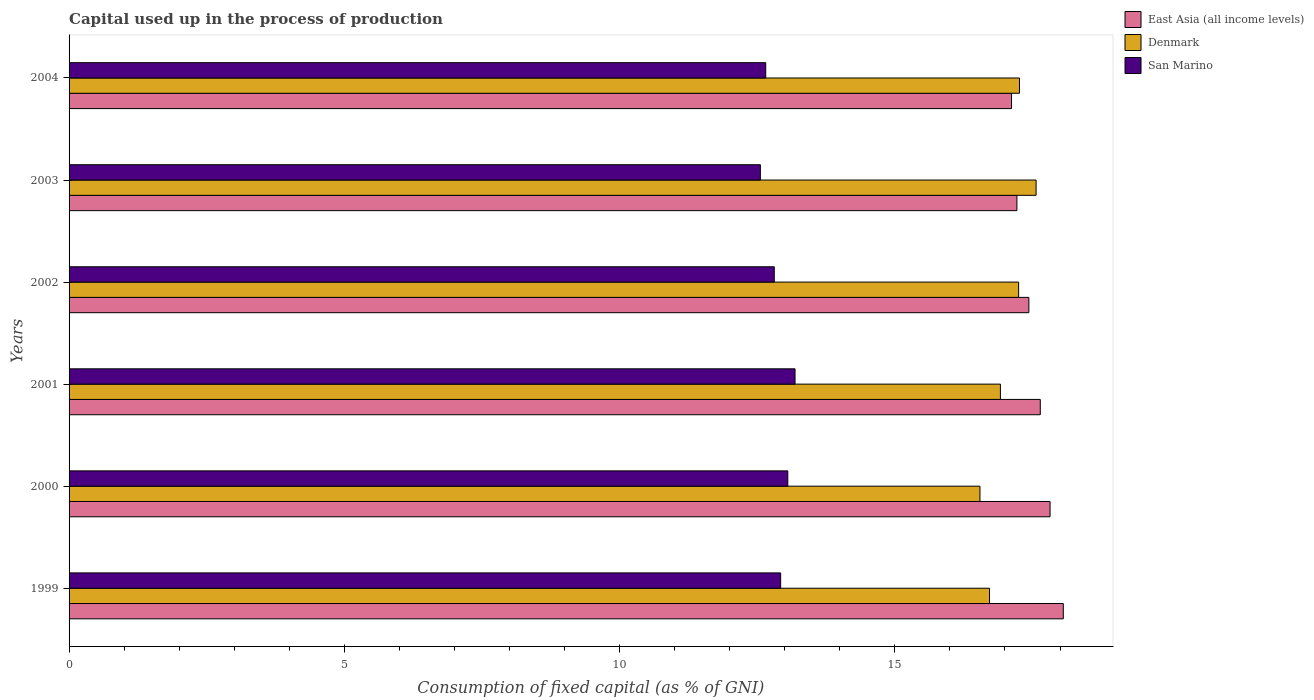How many different coloured bars are there?
Provide a succinct answer. 3. How many groups of bars are there?
Make the answer very short. 6. Are the number of bars per tick equal to the number of legend labels?
Provide a short and direct response. Yes. How many bars are there on the 5th tick from the top?
Provide a succinct answer. 3. In how many cases, is the number of bars for a given year not equal to the number of legend labels?
Make the answer very short. 0. What is the capital used up in the process of production in San Marino in 2004?
Offer a very short reply. 12.65. Across all years, what is the maximum capital used up in the process of production in San Marino?
Provide a succinct answer. 13.19. Across all years, what is the minimum capital used up in the process of production in San Marino?
Your answer should be compact. 12.56. What is the total capital used up in the process of production in East Asia (all income levels) in the graph?
Provide a short and direct response. 105.29. What is the difference between the capital used up in the process of production in Denmark in 2000 and that in 2001?
Your answer should be compact. -0.37. What is the difference between the capital used up in the process of production in Denmark in 2000 and the capital used up in the process of production in East Asia (all income levels) in 1999?
Your answer should be very brief. -1.51. What is the average capital used up in the process of production in East Asia (all income levels) per year?
Give a very brief answer. 17.55. In the year 2003, what is the difference between the capital used up in the process of production in Denmark and capital used up in the process of production in East Asia (all income levels)?
Offer a terse response. 0.35. What is the ratio of the capital used up in the process of production in Denmark in 2001 to that in 2002?
Your answer should be compact. 0.98. Is the difference between the capital used up in the process of production in Denmark in 1999 and 2000 greater than the difference between the capital used up in the process of production in East Asia (all income levels) in 1999 and 2000?
Your answer should be compact. No. What is the difference between the highest and the second highest capital used up in the process of production in East Asia (all income levels)?
Your answer should be compact. 0.24. What is the difference between the highest and the lowest capital used up in the process of production in Denmark?
Offer a terse response. 1.02. Is the sum of the capital used up in the process of production in Denmark in 1999 and 2003 greater than the maximum capital used up in the process of production in San Marino across all years?
Your answer should be compact. Yes. What does the 1st bar from the top in 1999 represents?
Your answer should be very brief. San Marino. How many bars are there?
Keep it short and to the point. 18. Are all the bars in the graph horizontal?
Ensure brevity in your answer.  Yes. How many years are there in the graph?
Provide a short and direct response. 6. Does the graph contain any zero values?
Your answer should be very brief. No. Does the graph contain grids?
Give a very brief answer. No. Where does the legend appear in the graph?
Offer a terse response. Top right. How many legend labels are there?
Keep it short and to the point. 3. How are the legend labels stacked?
Your answer should be compact. Vertical. What is the title of the graph?
Offer a terse response. Capital used up in the process of production. Does "Belgium" appear as one of the legend labels in the graph?
Your response must be concise. No. What is the label or title of the X-axis?
Your response must be concise. Consumption of fixed capital (as % of GNI). What is the Consumption of fixed capital (as % of GNI) in East Asia (all income levels) in 1999?
Ensure brevity in your answer.  18.06. What is the Consumption of fixed capital (as % of GNI) of Denmark in 1999?
Your response must be concise. 16.72. What is the Consumption of fixed capital (as % of GNI) of San Marino in 1999?
Your answer should be compact. 12.93. What is the Consumption of fixed capital (as % of GNI) in East Asia (all income levels) in 2000?
Provide a short and direct response. 17.82. What is the Consumption of fixed capital (as % of GNI) in Denmark in 2000?
Ensure brevity in your answer.  16.55. What is the Consumption of fixed capital (as % of GNI) in San Marino in 2000?
Your answer should be very brief. 13.06. What is the Consumption of fixed capital (as % of GNI) in East Asia (all income levels) in 2001?
Your answer should be compact. 17.64. What is the Consumption of fixed capital (as % of GNI) of Denmark in 2001?
Your answer should be very brief. 16.92. What is the Consumption of fixed capital (as % of GNI) of San Marino in 2001?
Keep it short and to the point. 13.19. What is the Consumption of fixed capital (as % of GNI) of East Asia (all income levels) in 2002?
Give a very brief answer. 17.43. What is the Consumption of fixed capital (as % of GNI) of Denmark in 2002?
Your response must be concise. 17.25. What is the Consumption of fixed capital (as % of GNI) in San Marino in 2002?
Your answer should be compact. 12.81. What is the Consumption of fixed capital (as % of GNI) in East Asia (all income levels) in 2003?
Offer a terse response. 17.22. What is the Consumption of fixed capital (as % of GNI) in Denmark in 2003?
Provide a succinct answer. 17.57. What is the Consumption of fixed capital (as % of GNI) of San Marino in 2003?
Offer a very short reply. 12.56. What is the Consumption of fixed capital (as % of GNI) in East Asia (all income levels) in 2004?
Keep it short and to the point. 17.12. What is the Consumption of fixed capital (as % of GNI) in Denmark in 2004?
Make the answer very short. 17.26. What is the Consumption of fixed capital (as % of GNI) in San Marino in 2004?
Keep it short and to the point. 12.65. Across all years, what is the maximum Consumption of fixed capital (as % of GNI) in East Asia (all income levels)?
Make the answer very short. 18.06. Across all years, what is the maximum Consumption of fixed capital (as % of GNI) of Denmark?
Your answer should be compact. 17.57. Across all years, what is the maximum Consumption of fixed capital (as % of GNI) in San Marino?
Make the answer very short. 13.19. Across all years, what is the minimum Consumption of fixed capital (as % of GNI) of East Asia (all income levels)?
Provide a succinct answer. 17.12. Across all years, what is the minimum Consumption of fixed capital (as % of GNI) in Denmark?
Ensure brevity in your answer.  16.55. Across all years, what is the minimum Consumption of fixed capital (as % of GNI) in San Marino?
Keep it short and to the point. 12.56. What is the total Consumption of fixed capital (as % of GNI) of East Asia (all income levels) in the graph?
Give a very brief answer. 105.29. What is the total Consumption of fixed capital (as % of GNI) in Denmark in the graph?
Ensure brevity in your answer.  102.26. What is the total Consumption of fixed capital (as % of GNI) of San Marino in the graph?
Give a very brief answer. 77.19. What is the difference between the Consumption of fixed capital (as % of GNI) in East Asia (all income levels) in 1999 and that in 2000?
Offer a very short reply. 0.24. What is the difference between the Consumption of fixed capital (as % of GNI) of Denmark in 1999 and that in 2000?
Your answer should be compact. 0.17. What is the difference between the Consumption of fixed capital (as % of GNI) in San Marino in 1999 and that in 2000?
Keep it short and to the point. -0.13. What is the difference between the Consumption of fixed capital (as % of GNI) of East Asia (all income levels) in 1999 and that in 2001?
Keep it short and to the point. 0.42. What is the difference between the Consumption of fixed capital (as % of GNI) in Denmark in 1999 and that in 2001?
Provide a succinct answer. -0.2. What is the difference between the Consumption of fixed capital (as % of GNI) in San Marino in 1999 and that in 2001?
Offer a terse response. -0.26. What is the difference between the Consumption of fixed capital (as % of GNI) of East Asia (all income levels) in 1999 and that in 2002?
Your response must be concise. 0.63. What is the difference between the Consumption of fixed capital (as % of GNI) in Denmark in 1999 and that in 2002?
Your answer should be very brief. -0.53. What is the difference between the Consumption of fixed capital (as % of GNI) in San Marino in 1999 and that in 2002?
Give a very brief answer. 0.12. What is the difference between the Consumption of fixed capital (as % of GNI) of East Asia (all income levels) in 1999 and that in 2003?
Provide a succinct answer. 0.84. What is the difference between the Consumption of fixed capital (as % of GNI) of Denmark in 1999 and that in 2003?
Make the answer very short. -0.85. What is the difference between the Consumption of fixed capital (as % of GNI) of San Marino in 1999 and that in 2003?
Ensure brevity in your answer.  0.37. What is the difference between the Consumption of fixed capital (as % of GNI) of East Asia (all income levels) in 1999 and that in 2004?
Provide a short and direct response. 0.94. What is the difference between the Consumption of fixed capital (as % of GNI) in Denmark in 1999 and that in 2004?
Your answer should be compact. -0.54. What is the difference between the Consumption of fixed capital (as % of GNI) in San Marino in 1999 and that in 2004?
Ensure brevity in your answer.  0.27. What is the difference between the Consumption of fixed capital (as % of GNI) of East Asia (all income levels) in 2000 and that in 2001?
Provide a succinct answer. 0.18. What is the difference between the Consumption of fixed capital (as % of GNI) in Denmark in 2000 and that in 2001?
Offer a terse response. -0.37. What is the difference between the Consumption of fixed capital (as % of GNI) of San Marino in 2000 and that in 2001?
Offer a terse response. -0.13. What is the difference between the Consumption of fixed capital (as % of GNI) in East Asia (all income levels) in 2000 and that in 2002?
Your answer should be compact. 0.38. What is the difference between the Consumption of fixed capital (as % of GNI) of Denmark in 2000 and that in 2002?
Offer a very short reply. -0.7. What is the difference between the Consumption of fixed capital (as % of GNI) in San Marino in 2000 and that in 2002?
Provide a short and direct response. 0.25. What is the difference between the Consumption of fixed capital (as % of GNI) of East Asia (all income levels) in 2000 and that in 2003?
Your answer should be very brief. 0.6. What is the difference between the Consumption of fixed capital (as % of GNI) in Denmark in 2000 and that in 2003?
Keep it short and to the point. -1.02. What is the difference between the Consumption of fixed capital (as % of GNI) in San Marino in 2000 and that in 2003?
Provide a short and direct response. 0.5. What is the difference between the Consumption of fixed capital (as % of GNI) in East Asia (all income levels) in 2000 and that in 2004?
Your response must be concise. 0.7. What is the difference between the Consumption of fixed capital (as % of GNI) of Denmark in 2000 and that in 2004?
Provide a short and direct response. -0.72. What is the difference between the Consumption of fixed capital (as % of GNI) of San Marino in 2000 and that in 2004?
Make the answer very short. 0.4. What is the difference between the Consumption of fixed capital (as % of GNI) in East Asia (all income levels) in 2001 and that in 2002?
Keep it short and to the point. 0.21. What is the difference between the Consumption of fixed capital (as % of GNI) of Denmark in 2001 and that in 2002?
Provide a succinct answer. -0.33. What is the difference between the Consumption of fixed capital (as % of GNI) of San Marino in 2001 and that in 2002?
Provide a short and direct response. 0.38. What is the difference between the Consumption of fixed capital (as % of GNI) of East Asia (all income levels) in 2001 and that in 2003?
Provide a succinct answer. 0.42. What is the difference between the Consumption of fixed capital (as % of GNI) of Denmark in 2001 and that in 2003?
Your answer should be very brief. -0.65. What is the difference between the Consumption of fixed capital (as % of GNI) of San Marino in 2001 and that in 2003?
Make the answer very short. 0.63. What is the difference between the Consumption of fixed capital (as % of GNI) of East Asia (all income levels) in 2001 and that in 2004?
Offer a very short reply. 0.52. What is the difference between the Consumption of fixed capital (as % of GNI) of Denmark in 2001 and that in 2004?
Make the answer very short. -0.35. What is the difference between the Consumption of fixed capital (as % of GNI) of San Marino in 2001 and that in 2004?
Ensure brevity in your answer.  0.53. What is the difference between the Consumption of fixed capital (as % of GNI) of East Asia (all income levels) in 2002 and that in 2003?
Your response must be concise. 0.22. What is the difference between the Consumption of fixed capital (as % of GNI) in Denmark in 2002 and that in 2003?
Make the answer very short. -0.32. What is the difference between the Consumption of fixed capital (as % of GNI) of San Marino in 2002 and that in 2003?
Provide a short and direct response. 0.25. What is the difference between the Consumption of fixed capital (as % of GNI) of East Asia (all income levels) in 2002 and that in 2004?
Your response must be concise. 0.32. What is the difference between the Consumption of fixed capital (as % of GNI) of Denmark in 2002 and that in 2004?
Keep it short and to the point. -0.02. What is the difference between the Consumption of fixed capital (as % of GNI) of San Marino in 2002 and that in 2004?
Give a very brief answer. 0.15. What is the difference between the Consumption of fixed capital (as % of GNI) in East Asia (all income levels) in 2003 and that in 2004?
Your answer should be very brief. 0.1. What is the difference between the Consumption of fixed capital (as % of GNI) in Denmark in 2003 and that in 2004?
Your answer should be compact. 0.3. What is the difference between the Consumption of fixed capital (as % of GNI) of San Marino in 2003 and that in 2004?
Your response must be concise. -0.1. What is the difference between the Consumption of fixed capital (as % of GNI) of East Asia (all income levels) in 1999 and the Consumption of fixed capital (as % of GNI) of Denmark in 2000?
Your answer should be compact. 1.51. What is the difference between the Consumption of fixed capital (as % of GNI) in East Asia (all income levels) in 1999 and the Consumption of fixed capital (as % of GNI) in San Marino in 2000?
Give a very brief answer. 5. What is the difference between the Consumption of fixed capital (as % of GNI) in Denmark in 1999 and the Consumption of fixed capital (as % of GNI) in San Marino in 2000?
Offer a terse response. 3.66. What is the difference between the Consumption of fixed capital (as % of GNI) of East Asia (all income levels) in 1999 and the Consumption of fixed capital (as % of GNI) of Denmark in 2001?
Your answer should be very brief. 1.14. What is the difference between the Consumption of fixed capital (as % of GNI) in East Asia (all income levels) in 1999 and the Consumption of fixed capital (as % of GNI) in San Marino in 2001?
Your response must be concise. 4.87. What is the difference between the Consumption of fixed capital (as % of GNI) in Denmark in 1999 and the Consumption of fixed capital (as % of GNI) in San Marino in 2001?
Keep it short and to the point. 3.53. What is the difference between the Consumption of fixed capital (as % of GNI) in East Asia (all income levels) in 1999 and the Consumption of fixed capital (as % of GNI) in Denmark in 2002?
Provide a short and direct response. 0.81. What is the difference between the Consumption of fixed capital (as % of GNI) of East Asia (all income levels) in 1999 and the Consumption of fixed capital (as % of GNI) of San Marino in 2002?
Your response must be concise. 5.25. What is the difference between the Consumption of fixed capital (as % of GNI) in Denmark in 1999 and the Consumption of fixed capital (as % of GNI) in San Marino in 2002?
Your answer should be very brief. 3.91. What is the difference between the Consumption of fixed capital (as % of GNI) in East Asia (all income levels) in 1999 and the Consumption of fixed capital (as % of GNI) in Denmark in 2003?
Offer a very short reply. 0.49. What is the difference between the Consumption of fixed capital (as % of GNI) of East Asia (all income levels) in 1999 and the Consumption of fixed capital (as % of GNI) of San Marino in 2003?
Your answer should be very brief. 5.5. What is the difference between the Consumption of fixed capital (as % of GNI) in Denmark in 1999 and the Consumption of fixed capital (as % of GNI) in San Marino in 2003?
Give a very brief answer. 4.16. What is the difference between the Consumption of fixed capital (as % of GNI) of East Asia (all income levels) in 1999 and the Consumption of fixed capital (as % of GNI) of Denmark in 2004?
Your response must be concise. 0.8. What is the difference between the Consumption of fixed capital (as % of GNI) in East Asia (all income levels) in 1999 and the Consumption of fixed capital (as % of GNI) in San Marino in 2004?
Your answer should be very brief. 5.4. What is the difference between the Consumption of fixed capital (as % of GNI) in Denmark in 1999 and the Consumption of fixed capital (as % of GNI) in San Marino in 2004?
Give a very brief answer. 4.06. What is the difference between the Consumption of fixed capital (as % of GNI) in East Asia (all income levels) in 2000 and the Consumption of fixed capital (as % of GNI) in Denmark in 2001?
Make the answer very short. 0.9. What is the difference between the Consumption of fixed capital (as % of GNI) in East Asia (all income levels) in 2000 and the Consumption of fixed capital (as % of GNI) in San Marino in 2001?
Your response must be concise. 4.63. What is the difference between the Consumption of fixed capital (as % of GNI) in Denmark in 2000 and the Consumption of fixed capital (as % of GNI) in San Marino in 2001?
Your response must be concise. 3.36. What is the difference between the Consumption of fixed capital (as % of GNI) in East Asia (all income levels) in 2000 and the Consumption of fixed capital (as % of GNI) in Denmark in 2002?
Your answer should be very brief. 0.57. What is the difference between the Consumption of fixed capital (as % of GNI) in East Asia (all income levels) in 2000 and the Consumption of fixed capital (as % of GNI) in San Marino in 2002?
Give a very brief answer. 5.01. What is the difference between the Consumption of fixed capital (as % of GNI) in Denmark in 2000 and the Consumption of fixed capital (as % of GNI) in San Marino in 2002?
Give a very brief answer. 3.74. What is the difference between the Consumption of fixed capital (as % of GNI) in East Asia (all income levels) in 2000 and the Consumption of fixed capital (as % of GNI) in Denmark in 2003?
Your answer should be compact. 0.25. What is the difference between the Consumption of fixed capital (as % of GNI) of East Asia (all income levels) in 2000 and the Consumption of fixed capital (as % of GNI) of San Marino in 2003?
Provide a short and direct response. 5.26. What is the difference between the Consumption of fixed capital (as % of GNI) in Denmark in 2000 and the Consumption of fixed capital (as % of GNI) in San Marino in 2003?
Make the answer very short. 3.99. What is the difference between the Consumption of fixed capital (as % of GNI) in East Asia (all income levels) in 2000 and the Consumption of fixed capital (as % of GNI) in Denmark in 2004?
Your answer should be compact. 0.56. What is the difference between the Consumption of fixed capital (as % of GNI) in East Asia (all income levels) in 2000 and the Consumption of fixed capital (as % of GNI) in San Marino in 2004?
Offer a very short reply. 5.16. What is the difference between the Consumption of fixed capital (as % of GNI) of Denmark in 2000 and the Consumption of fixed capital (as % of GNI) of San Marino in 2004?
Give a very brief answer. 3.89. What is the difference between the Consumption of fixed capital (as % of GNI) of East Asia (all income levels) in 2001 and the Consumption of fixed capital (as % of GNI) of Denmark in 2002?
Your response must be concise. 0.39. What is the difference between the Consumption of fixed capital (as % of GNI) in East Asia (all income levels) in 2001 and the Consumption of fixed capital (as % of GNI) in San Marino in 2002?
Provide a succinct answer. 4.83. What is the difference between the Consumption of fixed capital (as % of GNI) in Denmark in 2001 and the Consumption of fixed capital (as % of GNI) in San Marino in 2002?
Offer a terse response. 4.11. What is the difference between the Consumption of fixed capital (as % of GNI) in East Asia (all income levels) in 2001 and the Consumption of fixed capital (as % of GNI) in Denmark in 2003?
Your answer should be very brief. 0.08. What is the difference between the Consumption of fixed capital (as % of GNI) in East Asia (all income levels) in 2001 and the Consumption of fixed capital (as % of GNI) in San Marino in 2003?
Offer a terse response. 5.08. What is the difference between the Consumption of fixed capital (as % of GNI) in Denmark in 2001 and the Consumption of fixed capital (as % of GNI) in San Marino in 2003?
Provide a succinct answer. 4.36. What is the difference between the Consumption of fixed capital (as % of GNI) of East Asia (all income levels) in 2001 and the Consumption of fixed capital (as % of GNI) of Denmark in 2004?
Keep it short and to the point. 0.38. What is the difference between the Consumption of fixed capital (as % of GNI) in East Asia (all income levels) in 2001 and the Consumption of fixed capital (as % of GNI) in San Marino in 2004?
Provide a succinct answer. 4.99. What is the difference between the Consumption of fixed capital (as % of GNI) in Denmark in 2001 and the Consumption of fixed capital (as % of GNI) in San Marino in 2004?
Offer a terse response. 4.26. What is the difference between the Consumption of fixed capital (as % of GNI) of East Asia (all income levels) in 2002 and the Consumption of fixed capital (as % of GNI) of Denmark in 2003?
Offer a very short reply. -0.13. What is the difference between the Consumption of fixed capital (as % of GNI) in East Asia (all income levels) in 2002 and the Consumption of fixed capital (as % of GNI) in San Marino in 2003?
Offer a very short reply. 4.88. What is the difference between the Consumption of fixed capital (as % of GNI) in Denmark in 2002 and the Consumption of fixed capital (as % of GNI) in San Marino in 2003?
Make the answer very short. 4.69. What is the difference between the Consumption of fixed capital (as % of GNI) in East Asia (all income levels) in 2002 and the Consumption of fixed capital (as % of GNI) in Denmark in 2004?
Your response must be concise. 0.17. What is the difference between the Consumption of fixed capital (as % of GNI) of East Asia (all income levels) in 2002 and the Consumption of fixed capital (as % of GNI) of San Marino in 2004?
Offer a very short reply. 4.78. What is the difference between the Consumption of fixed capital (as % of GNI) in Denmark in 2002 and the Consumption of fixed capital (as % of GNI) in San Marino in 2004?
Your response must be concise. 4.59. What is the difference between the Consumption of fixed capital (as % of GNI) of East Asia (all income levels) in 2003 and the Consumption of fixed capital (as % of GNI) of Denmark in 2004?
Offer a very short reply. -0.05. What is the difference between the Consumption of fixed capital (as % of GNI) of East Asia (all income levels) in 2003 and the Consumption of fixed capital (as % of GNI) of San Marino in 2004?
Make the answer very short. 4.56. What is the difference between the Consumption of fixed capital (as % of GNI) in Denmark in 2003 and the Consumption of fixed capital (as % of GNI) in San Marino in 2004?
Keep it short and to the point. 4.91. What is the average Consumption of fixed capital (as % of GNI) in East Asia (all income levels) per year?
Your answer should be compact. 17.55. What is the average Consumption of fixed capital (as % of GNI) in Denmark per year?
Your answer should be very brief. 17.04. What is the average Consumption of fixed capital (as % of GNI) of San Marino per year?
Your answer should be very brief. 12.86. In the year 1999, what is the difference between the Consumption of fixed capital (as % of GNI) in East Asia (all income levels) and Consumption of fixed capital (as % of GNI) in Denmark?
Offer a terse response. 1.34. In the year 1999, what is the difference between the Consumption of fixed capital (as % of GNI) in East Asia (all income levels) and Consumption of fixed capital (as % of GNI) in San Marino?
Keep it short and to the point. 5.13. In the year 1999, what is the difference between the Consumption of fixed capital (as % of GNI) of Denmark and Consumption of fixed capital (as % of GNI) of San Marino?
Your answer should be very brief. 3.79. In the year 2000, what is the difference between the Consumption of fixed capital (as % of GNI) in East Asia (all income levels) and Consumption of fixed capital (as % of GNI) in Denmark?
Make the answer very short. 1.27. In the year 2000, what is the difference between the Consumption of fixed capital (as % of GNI) in East Asia (all income levels) and Consumption of fixed capital (as % of GNI) in San Marino?
Provide a short and direct response. 4.76. In the year 2000, what is the difference between the Consumption of fixed capital (as % of GNI) in Denmark and Consumption of fixed capital (as % of GNI) in San Marino?
Provide a succinct answer. 3.49. In the year 2001, what is the difference between the Consumption of fixed capital (as % of GNI) in East Asia (all income levels) and Consumption of fixed capital (as % of GNI) in Denmark?
Your answer should be very brief. 0.72. In the year 2001, what is the difference between the Consumption of fixed capital (as % of GNI) in East Asia (all income levels) and Consumption of fixed capital (as % of GNI) in San Marino?
Your response must be concise. 4.45. In the year 2001, what is the difference between the Consumption of fixed capital (as % of GNI) of Denmark and Consumption of fixed capital (as % of GNI) of San Marino?
Offer a very short reply. 3.73. In the year 2002, what is the difference between the Consumption of fixed capital (as % of GNI) of East Asia (all income levels) and Consumption of fixed capital (as % of GNI) of Denmark?
Make the answer very short. 0.19. In the year 2002, what is the difference between the Consumption of fixed capital (as % of GNI) in East Asia (all income levels) and Consumption of fixed capital (as % of GNI) in San Marino?
Provide a succinct answer. 4.62. In the year 2002, what is the difference between the Consumption of fixed capital (as % of GNI) of Denmark and Consumption of fixed capital (as % of GNI) of San Marino?
Provide a succinct answer. 4.44. In the year 2003, what is the difference between the Consumption of fixed capital (as % of GNI) of East Asia (all income levels) and Consumption of fixed capital (as % of GNI) of Denmark?
Offer a terse response. -0.35. In the year 2003, what is the difference between the Consumption of fixed capital (as % of GNI) of East Asia (all income levels) and Consumption of fixed capital (as % of GNI) of San Marino?
Keep it short and to the point. 4.66. In the year 2003, what is the difference between the Consumption of fixed capital (as % of GNI) of Denmark and Consumption of fixed capital (as % of GNI) of San Marino?
Provide a succinct answer. 5.01. In the year 2004, what is the difference between the Consumption of fixed capital (as % of GNI) in East Asia (all income levels) and Consumption of fixed capital (as % of GNI) in Denmark?
Ensure brevity in your answer.  -0.14. In the year 2004, what is the difference between the Consumption of fixed capital (as % of GNI) of East Asia (all income levels) and Consumption of fixed capital (as % of GNI) of San Marino?
Provide a short and direct response. 4.46. In the year 2004, what is the difference between the Consumption of fixed capital (as % of GNI) in Denmark and Consumption of fixed capital (as % of GNI) in San Marino?
Give a very brief answer. 4.61. What is the ratio of the Consumption of fixed capital (as % of GNI) of East Asia (all income levels) in 1999 to that in 2000?
Keep it short and to the point. 1.01. What is the ratio of the Consumption of fixed capital (as % of GNI) in Denmark in 1999 to that in 2000?
Offer a terse response. 1.01. What is the ratio of the Consumption of fixed capital (as % of GNI) of East Asia (all income levels) in 1999 to that in 2001?
Provide a short and direct response. 1.02. What is the ratio of the Consumption of fixed capital (as % of GNI) in Denmark in 1999 to that in 2001?
Make the answer very short. 0.99. What is the ratio of the Consumption of fixed capital (as % of GNI) of San Marino in 1999 to that in 2001?
Ensure brevity in your answer.  0.98. What is the ratio of the Consumption of fixed capital (as % of GNI) in East Asia (all income levels) in 1999 to that in 2002?
Your answer should be very brief. 1.04. What is the ratio of the Consumption of fixed capital (as % of GNI) in Denmark in 1999 to that in 2002?
Keep it short and to the point. 0.97. What is the ratio of the Consumption of fixed capital (as % of GNI) of San Marino in 1999 to that in 2002?
Your answer should be compact. 1.01. What is the ratio of the Consumption of fixed capital (as % of GNI) in East Asia (all income levels) in 1999 to that in 2003?
Ensure brevity in your answer.  1.05. What is the ratio of the Consumption of fixed capital (as % of GNI) of Denmark in 1999 to that in 2003?
Your answer should be compact. 0.95. What is the ratio of the Consumption of fixed capital (as % of GNI) of San Marino in 1999 to that in 2003?
Offer a terse response. 1.03. What is the ratio of the Consumption of fixed capital (as % of GNI) in East Asia (all income levels) in 1999 to that in 2004?
Your answer should be very brief. 1.05. What is the ratio of the Consumption of fixed capital (as % of GNI) in Denmark in 1999 to that in 2004?
Give a very brief answer. 0.97. What is the ratio of the Consumption of fixed capital (as % of GNI) in San Marino in 1999 to that in 2004?
Give a very brief answer. 1.02. What is the ratio of the Consumption of fixed capital (as % of GNI) in East Asia (all income levels) in 2000 to that in 2001?
Make the answer very short. 1.01. What is the ratio of the Consumption of fixed capital (as % of GNI) of East Asia (all income levels) in 2000 to that in 2002?
Your answer should be compact. 1.02. What is the ratio of the Consumption of fixed capital (as % of GNI) in Denmark in 2000 to that in 2002?
Your response must be concise. 0.96. What is the ratio of the Consumption of fixed capital (as % of GNI) of San Marino in 2000 to that in 2002?
Keep it short and to the point. 1.02. What is the ratio of the Consumption of fixed capital (as % of GNI) of East Asia (all income levels) in 2000 to that in 2003?
Give a very brief answer. 1.03. What is the ratio of the Consumption of fixed capital (as % of GNI) of Denmark in 2000 to that in 2003?
Provide a short and direct response. 0.94. What is the ratio of the Consumption of fixed capital (as % of GNI) in San Marino in 2000 to that in 2003?
Provide a short and direct response. 1.04. What is the ratio of the Consumption of fixed capital (as % of GNI) of East Asia (all income levels) in 2000 to that in 2004?
Offer a terse response. 1.04. What is the ratio of the Consumption of fixed capital (as % of GNI) of Denmark in 2000 to that in 2004?
Offer a terse response. 0.96. What is the ratio of the Consumption of fixed capital (as % of GNI) of San Marino in 2000 to that in 2004?
Give a very brief answer. 1.03. What is the ratio of the Consumption of fixed capital (as % of GNI) in East Asia (all income levels) in 2001 to that in 2002?
Ensure brevity in your answer.  1.01. What is the ratio of the Consumption of fixed capital (as % of GNI) in Denmark in 2001 to that in 2002?
Give a very brief answer. 0.98. What is the ratio of the Consumption of fixed capital (as % of GNI) in San Marino in 2001 to that in 2002?
Make the answer very short. 1.03. What is the ratio of the Consumption of fixed capital (as % of GNI) of East Asia (all income levels) in 2001 to that in 2003?
Make the answer very short. 1.02. What is the ratio of the Consumption of fixed capital (as % of GNI) of Denmark in 2001 to that in 2003?
Provide a succinct answer. 0.96. What is the ratio of the Consumption of fixed capital (as % of GNI) of San Marino in 2001 to that in 2003?
Offer a very short reply. 1.05. What is the ratio of the Consumption of fixed capital (as % of GNI) in East Asia (all income levels) in 2001 to that in 2004?
Your answer should be compact. 1.03. What is the ratio of the Consumption of fixed capital (as % of GNI) in Denmark in 2001 to that in 2004?
Provide a succinct answer. 0.98. What is the ratio of the Consumption of fixed capital (as % of GNI) of San Marino in 2001 to that in 2004?
Keep it short and to the point. 1.04. What is the ratio of the Consumption of fixed capital (as % of GNI) in East Asia (all income levels) in 2002 to that in 2003?
Your answer should be very brief. 1.01. What is the ratio of the Consumption of fixed capital (as % of GNI) in Denmark in 2002 to that in 2003?
Offer a terse response. 0.98. What is the ratio of the Consumption of fixed capital (as % of GNI) in San Marino in 2002 to that in 2003?
Make the answer very short. 1.02. What is the ratio of the Consumption of fixed capital (as % of GNI) of East Asia (all income levels) in 2002 to that in 2004?
Provide a succinct answer. 1.02. What is the ratio of the Consumption of fixed capital (as % of GNI) in San Marino in 2002 to that in 2004?
Provide a short and direct response. 1.01. What is the ratio of the Consumption of fixed capital (as % of GNI) of East Asia (all income levels) in 2003 to that in 2004?
Your response must be concise. 1.01. What is the ratio of the Consumption of fixed capital (as % of GNI) in Denmark in 2003 to that in 2004?
Ensure brevity in your answer.  1.02. What is the ratio of the Consumption of fixed capital (as % of GNI) of San Marino in 2003 to that in 2004?
Ensure brevity in your answer.  0.99. What is the difference between the highest and the second highest Consumption of fixed capital (as % of GNI) of East Asia (all income levels)?
Give a very brief answer. 0.24. What is the difference between the highest and the second highest Consumption of fixed capital (as % of GNI) in Denmark?
Offer a very short reply. 0.3. What is the difference between the highest and the second highest Consumption of fixed capital (as % of GNI) in San Marino?
Keep it short and to the point. 0.13. What is the difference between the highest and the lowest Consumption of fixed capital (as % of GNI) of East Asia (all income levels)?
Provide a succinct answer. 0.94. What is the difference between the highest and the lowest Consumption of fixed capital (as % of GNI) in Denmark?
Provide a short and direct response. 1.02. What is the difference between the highest and the lowest Consumption of fixed capital (as % of GNI) in San Marino?
Make the answer very short. 0.63. 